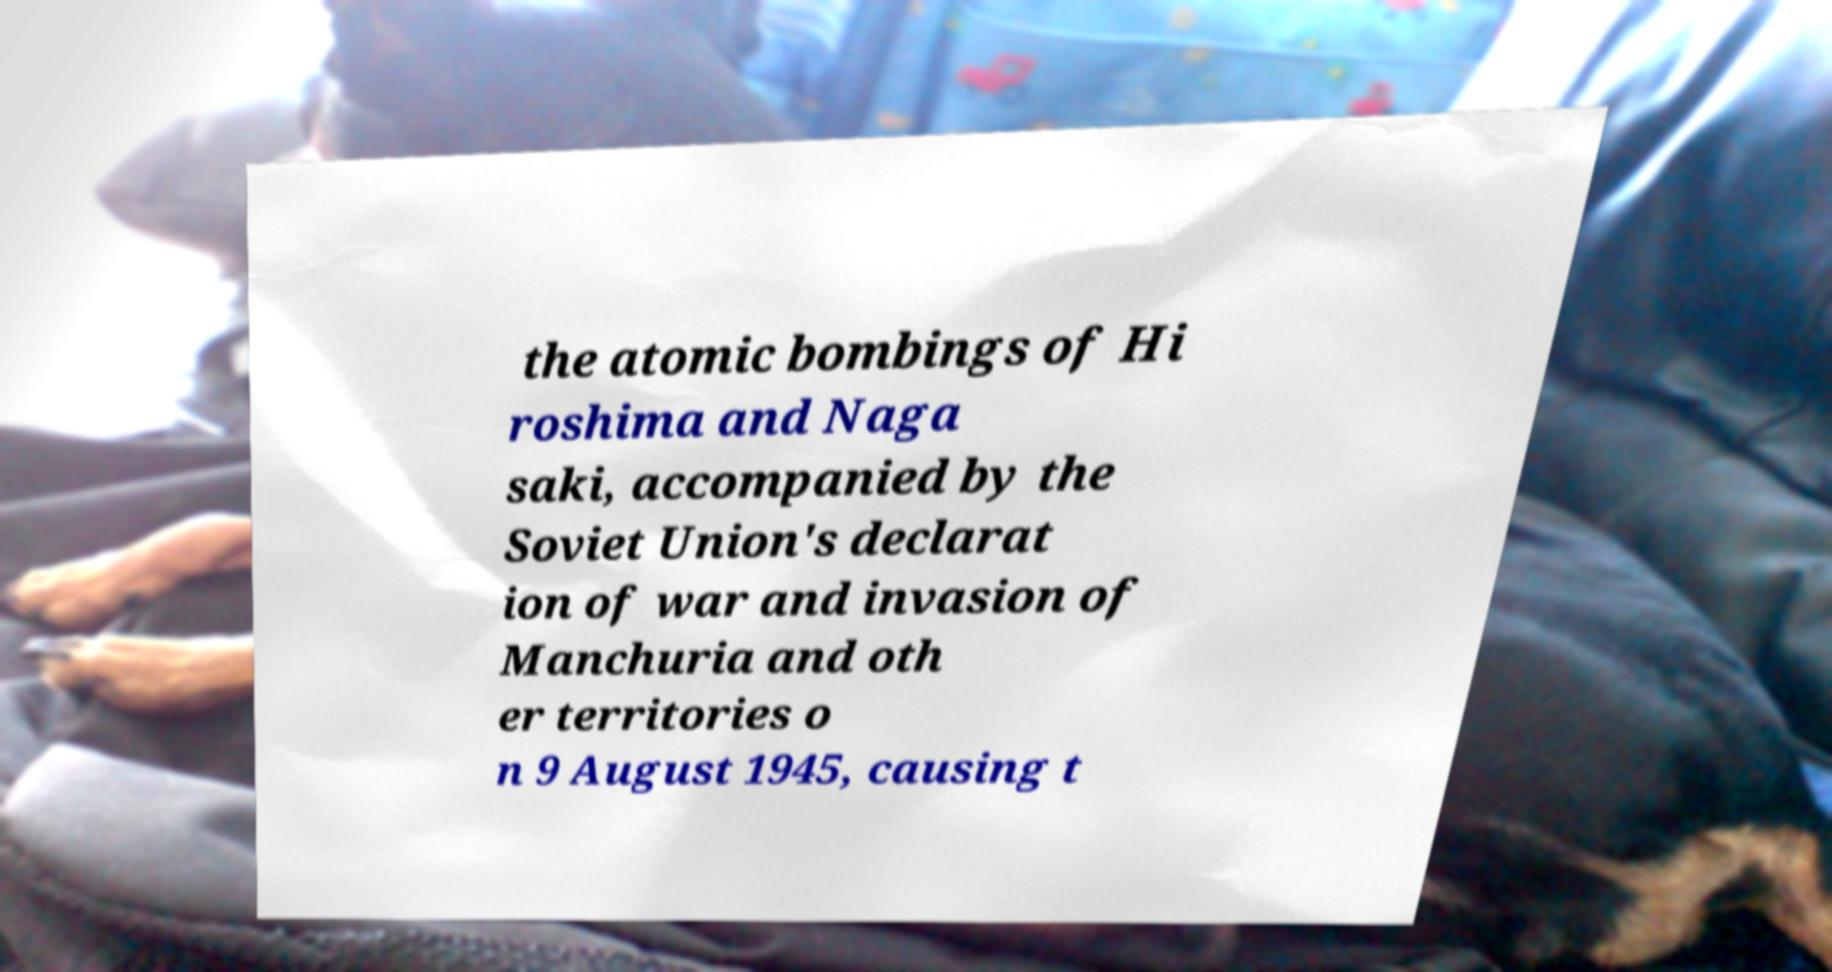For documentation purposes, I need the text within this image transcribed. Could you provide that? the atomic bombings of Hi roshima and Naga saki, accompanied by the Soviet Union's declarat ion of war and invasion of Manchuria and oth er territories o n 9 August 1945, causing t 